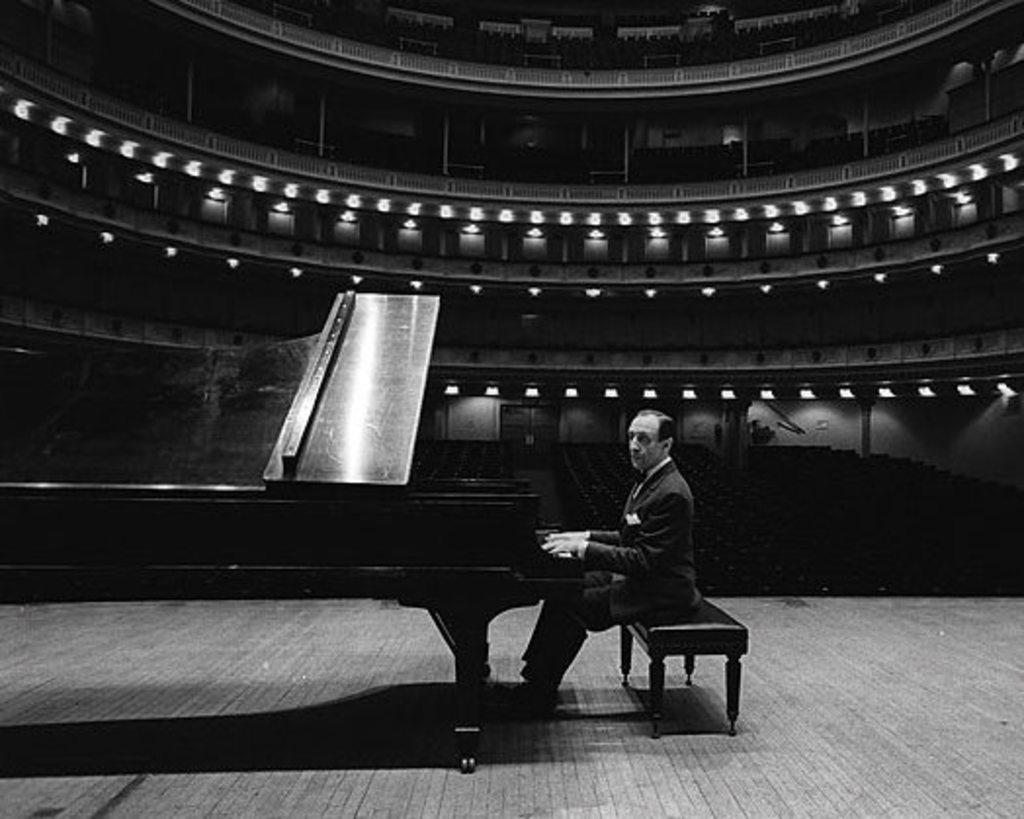Who is the person in the image? There is a man in the image. What is the man doing in the image? The man is playing a piano. Where is the man seated in the image? The man is seated on a bench. What is the environment like in the image? The setting is an open hall. What type of advice can be heard from the fish in the image? There are no fish present in the image, so no advice can be heard from them. 